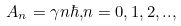Convert formula to latex. <formula><loc_0><loc_0><loc_500><loc_500>A _ { n } = \gamma n \hbar { , } n = 0 , 1 , 2 , . . ,</formula> 